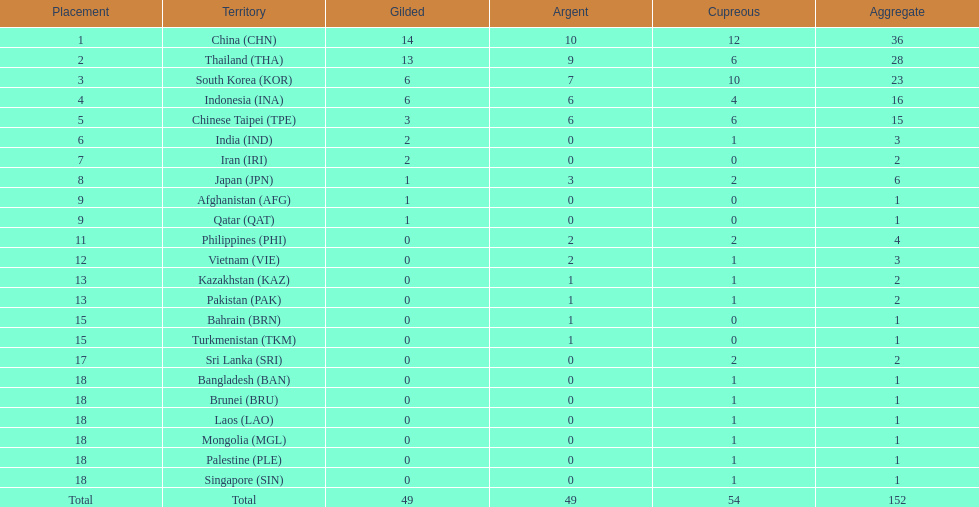How many nations received a medal in each gold, silver, and bronze? 6. 